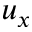Convert formula to latex. <formula><loc_0><loc_0><loc_500><loc_500>u _ { x }</formula> 